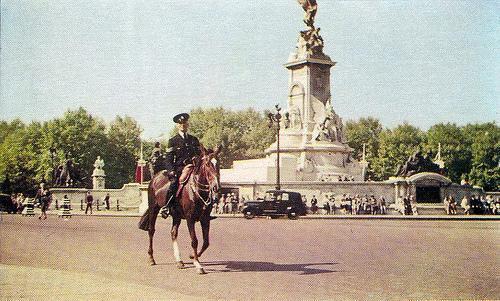How many horses are there?
Give a very brief answer. 1. How many horses are pictured?
Give a very brief answer. 1. How many people are riding horses?
Give a very brief answer. 1. How many people are running near horse?
Give a very brief answer. 0. 